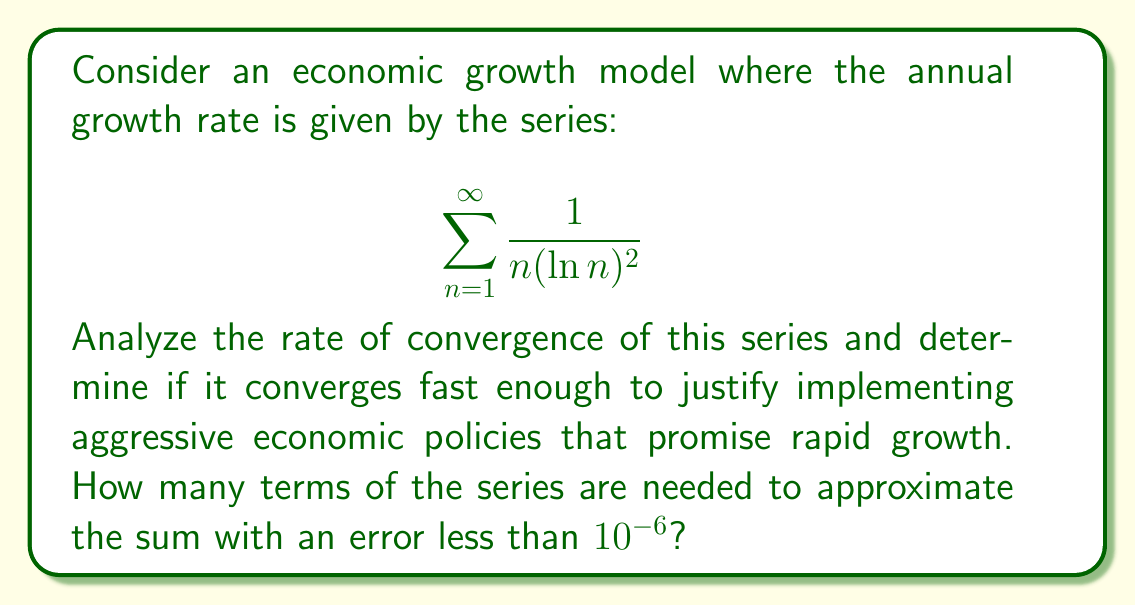What is the answer to this math problem? To analyze the rate of convergence, we'll use the integral test and compare the series to an integral.

1) First, let's prove that the series converges:
   Let $f(x) = \frac{1}{x(\ln x)^2}$ for $x \geq 2$. 
   
   $$\int_2^{\infty} \frac{1}{x(\ln x)^2} dx = [-\frac{1}{\ln x}]_2^{\infty} = 0 - (-\frac{1}{\ln 2}) = \frac{1}{\ln 2} < \infty$$

   Therefore, the series converges.

2) To find the rate of convergence, we'll use the remainder estimate:
   
   $$R_n = \sum_{k=n+1}^{\infty} \frac{1}{k(\ln k)^2} \leq \int_n^{\infty} \frac{1}{x(\ln x)^2} dx = \frac{1}{\ln n}$$

3) To find $n$ such that $R_n < 10^{-6}$, we solve:

   $$\frac{1}{\ln n} < 10^{-6}$$
   $$\ln n > 10^6$$
   $$n > e^{10^6} \approx 8.7 \times 10^{434294}$$

4) This extremely large number of terms indicates that the series converges very slowly.

5) To put this in perspective, even with a million terms, the error would still be approximately:

   $$R_{1,000,000} \approx \frac{1}{\ln(1,000,000)} \approx 0.0724$$

   Which is much larger than the desired $10^{-6}$ error.
Answer: The series converges extremely slowly. To achieve an error less than $10^{-6}$, more than $8.7 \times 10^{434294}$ terms would be needed, which is computationally infeasible. This slow convergence suggests that economic growth modeled by this series would be too gradual to justify aggressive economic policies promising rapid growth. 